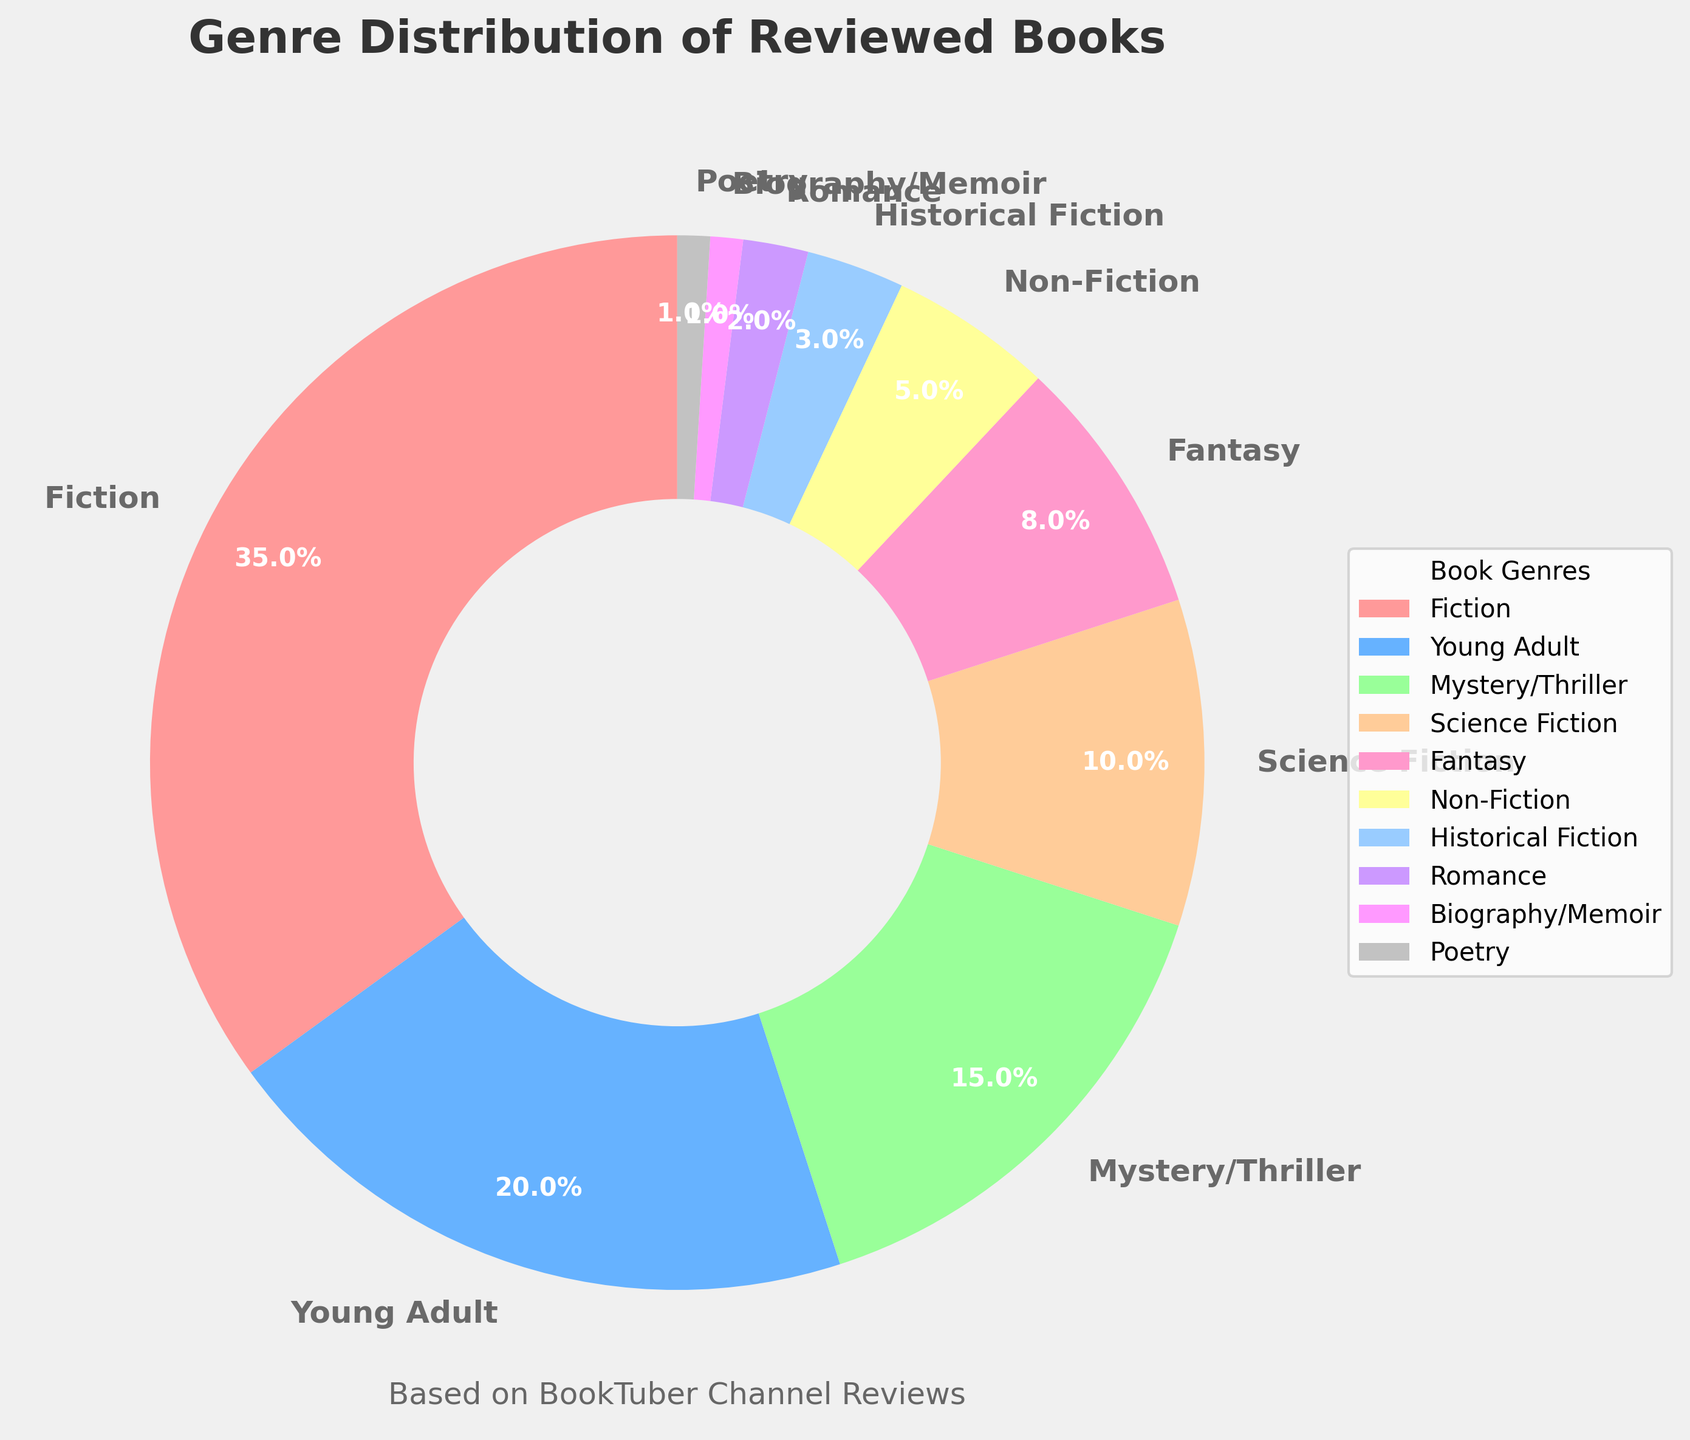What percentage of the reviewed books are Fiction? Fiction is represented by a slice labeled as "Fiction" with the percentage displayed as 35%.
Answer: 35% Which genre has the smallest percentage representation? By looking at the pie chart, the smallest slices are "Biography/Memoir" and "Poetry", both showing 1%.
Answer: Biography/Memoir, Poetry How many more Fiction books are reviewed compared to Fantasy books? The Fiction slice shows 35% and the Fantasy slice shows 8%. The difference is 35% - 8%.
Answer: 27% What is the combined percentage of Non-Fiction and Historical Fiction books? Non-Fiction is 5% and Historical Fiction is 3%. Adding these up gives 5% + 3%.
Answer: 8% Are Young Adult books reviewed more frequently than Science Fiction books? The Young Adult slice shows 20% while the Science Fiction slice shows 10%. Since 20% > 10%, Young Adult books are reviewed more frequently.
Answer: Yes Which genre has the second highest percentage of books reviewed? The highest percentage is Fiction with 35%, the next highest is Young Adult with 20%.
Answer: Young Adult If the total number of books reviewed is 200, how many Mystery/Thriller books were reviewed? Mystery/Thriller books have a 15% share. Calculating 15% of 200 gives 0.15 * 200.
Answer: 30 Do Romance books make up more than 5% of the reviewed books? Romance books are shown with a percentage of 2%, which is less than 5%.
Answer: No What is the percentage difference between Young Adult and Non-Fiction genres? Young Adult is shown with 20% and Non-Fiction with 5%. The difference is 20% - 5%.
Answer: 15% Is the percentage of Young Adult books reviewed twice as much as Mystery/Thriller books? Young Adult is 20% and Mystery/Thriller is 15%. Since 20% is not twice 15%, the answer is no.
Answer: No 